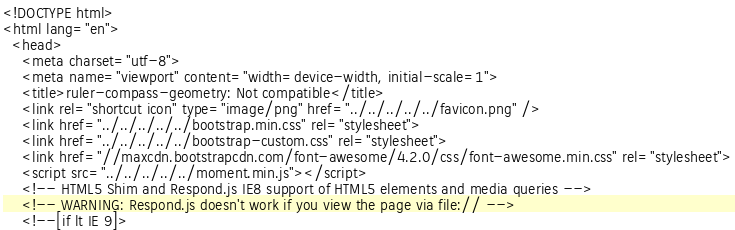<code> <loc_0><loc_0><loc_500><loc_500><_HTML_><!DOCTYPE html>
<html lang="en">
  <head>
    <meta charset="utf-8">
    <meta name="viewport" content="width=device-width, initial-scale=1">
    <title>ruler-compass-geometry: Not compatible</title>
    <link rel="shortcut icon" type="image/png" href="../../../../../favicon.png" />
    <link href="../../../../../bootstrap.min.css" rel="stylesheet">
    <link href="../../../../../bootstrap-custom.css" rel="stylesheet">
    <link href="//maxcdn.bootstrapcdn.com/font-awesome/4.2.0/css/font-awesome.min.css" rel="stylesheet">
    <script src="../../../../../moment.min.js"></script>
    <!-- HTML5 Shim and Respond.js IE8 support of HTML5 elements and media queries -->
    <!-- WARNING: Respond.js doesn't work if you view the page via file:// -->
    <!--[if lt IE 9]></code> 